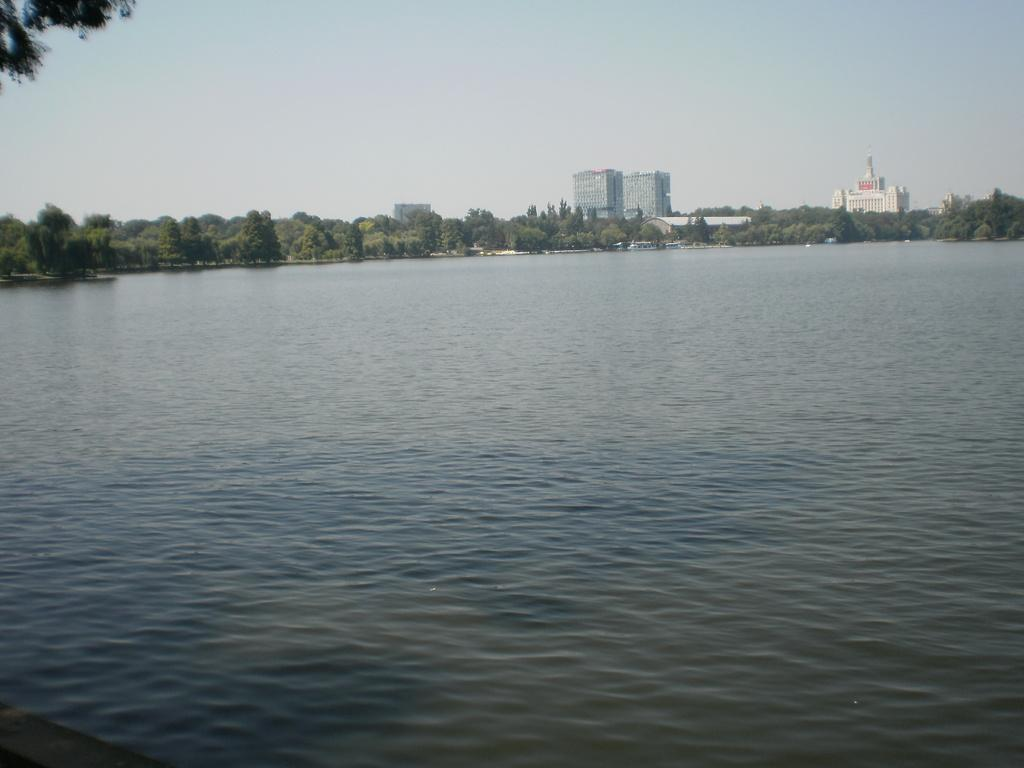What is located in the foreground of the image? There is a water body in the foreground of the image. What can be seen in the middle of the image? There are trees and buildings in the middle of the image. What is visible at the top of the image? The sky is visible at the top of the image. What type of shop can be seen in the image? There is no shop present in the image. What thought is being expressed by the trees in the image? Trees do not express thoughts, so this question cannot be answered. 